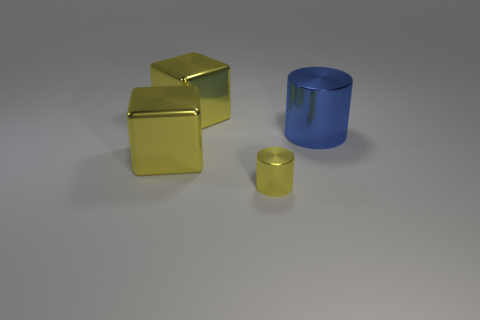Subtract all blue blocks. Subtract all green cylinders. How many blocks are left? 2 Subtract all yellow cylinders. How many brown blocks are left? 0 Add 1 purples. How many small objects exist? 0 Subtract all small objects. Subtract all big yellow shiny objects. How many objects are left? 1 Add 3 big yellow metallic things. How many big yellow metallic things are left? 5 Add 2 small yellow metal balls. How many small yellow metal balls exist? 2 Add 1 blue cylinders. How many objects exist? 5 Subtract all yellow cylinders. How many cylinders are left? 1 Subtract 0 brown cubes. How many objects are left? 4 Subtract 2 blocks. How many blocks are left? 0 